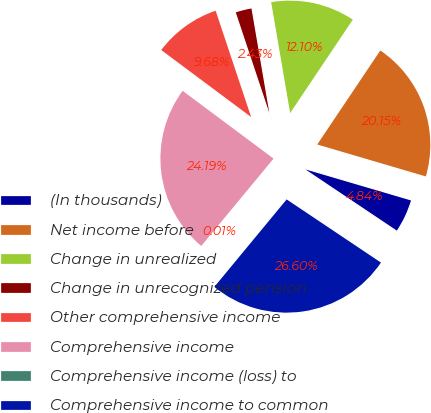Convert chart. <chart><loc_0><loc_0><loc_500><loc_500><pie_chart><fcel>(In thousands)<fcel>Net income before<fcel>Change in unrealized<fcel>Change in unrecognized pension<fcel>Other comprehensive income<fcel>Comprehensive income<fcel>Comprehensive income (loss) to<fcel>Comprehensive income to common<nl><fcel>4.84%<fcel>20.15%<fcel>12.1%<fcel>2.43%<fcel>9.68%<fcel>24.19%<fcel>0.01%<fcel>26.6%<nl></chart> 